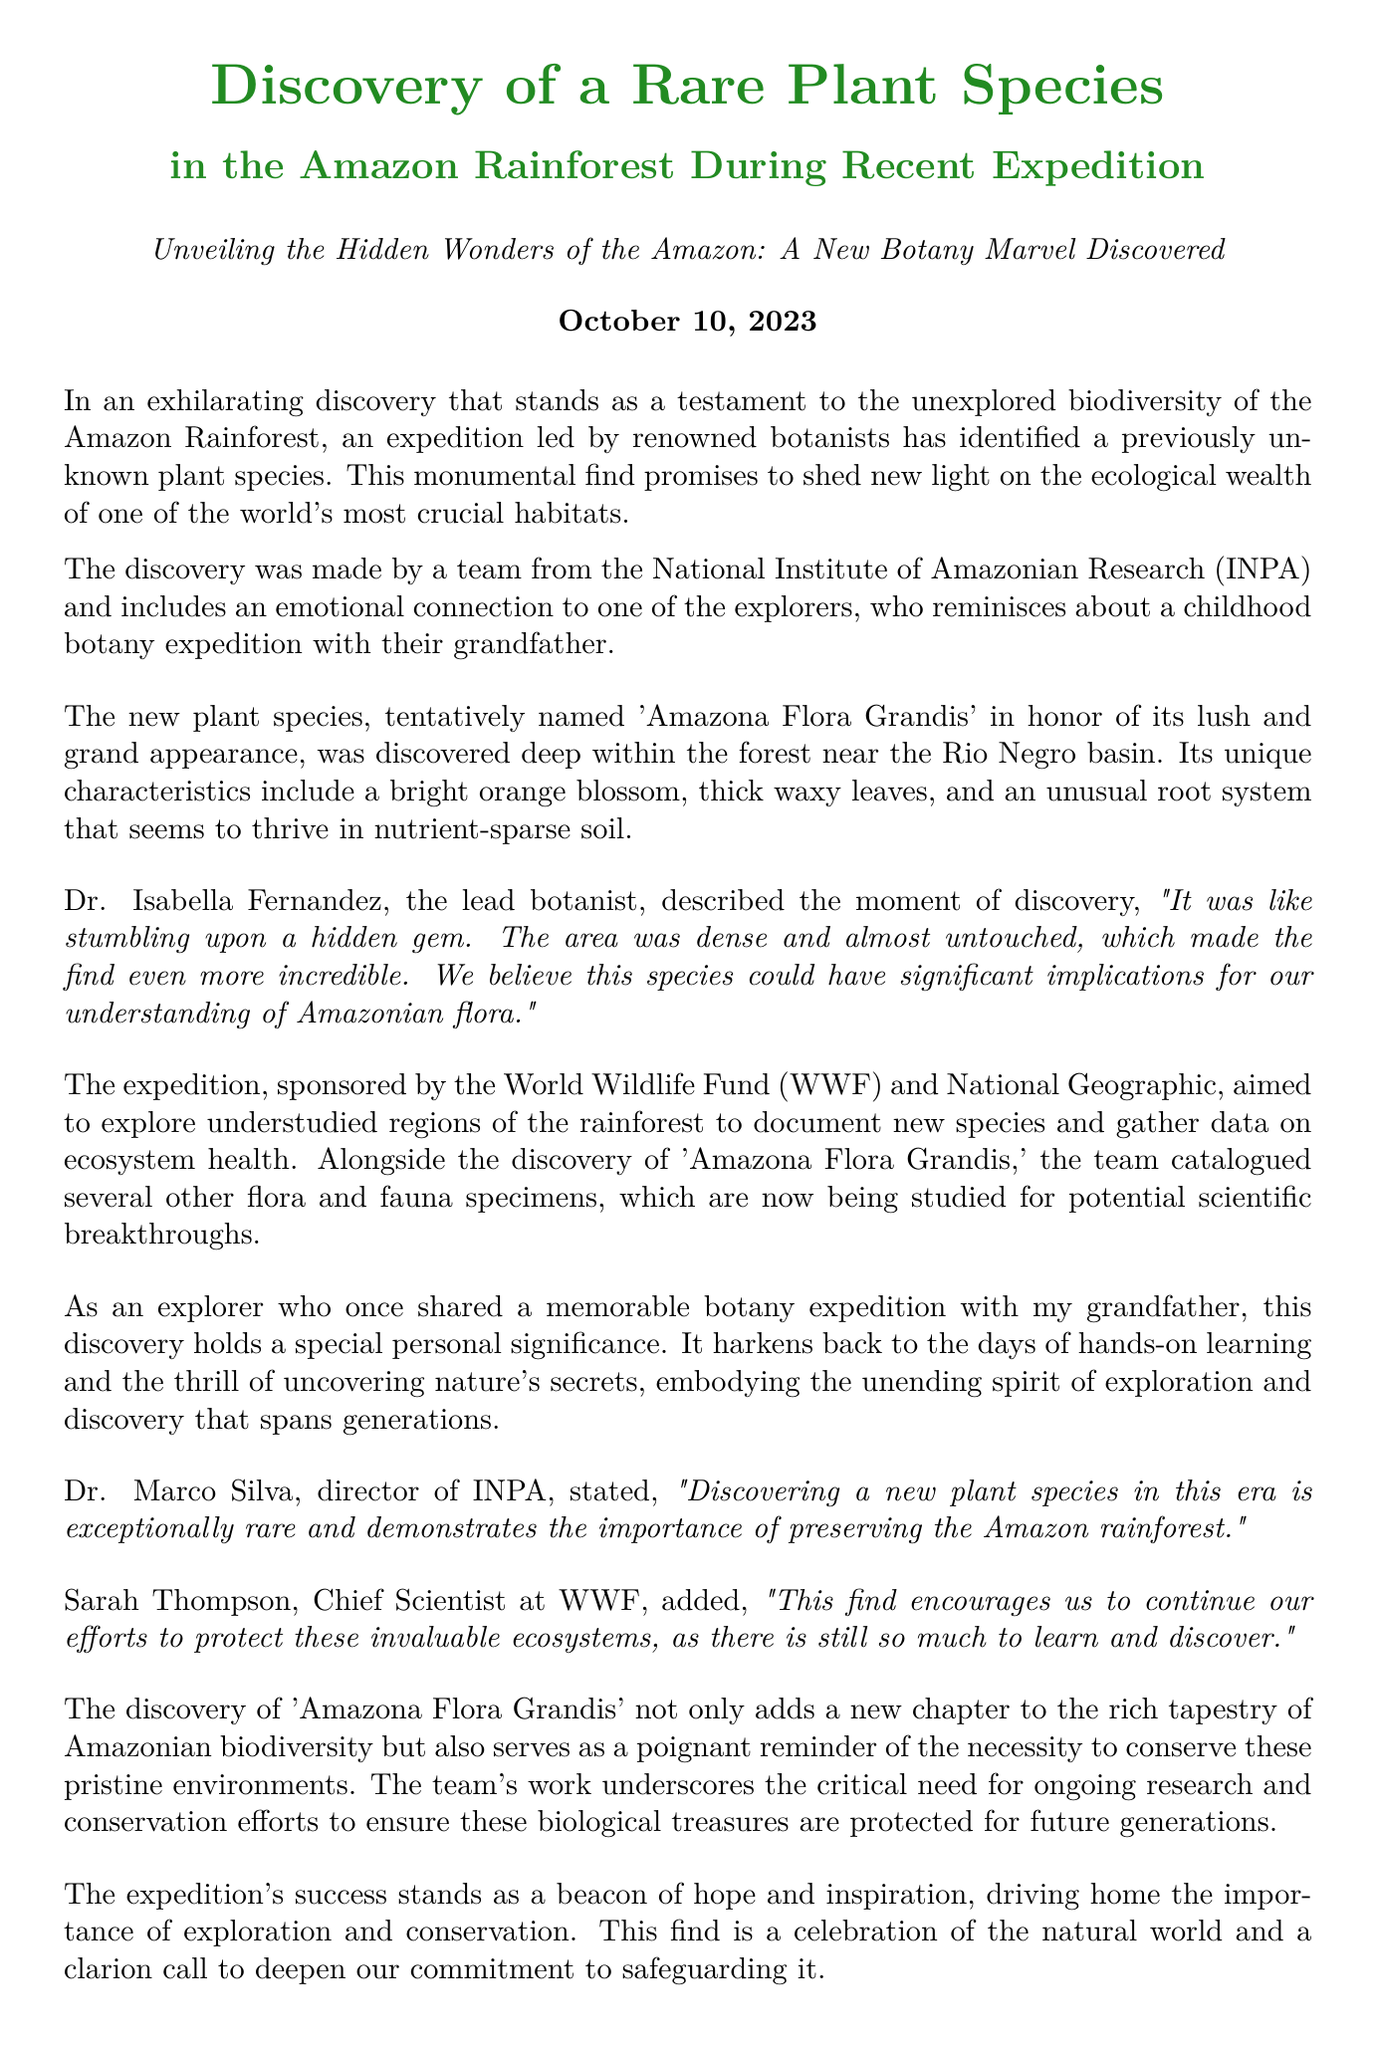What is the name of the new plant species? The new plant species is tentatively named in honor of its appearance, which is reflected in the name given in the document.
Answer: Amazona Flora Grandis Who led the expedition? The lead botanist is mentioned in the document as having described the moment of discovery, indicating her importance in the expedition.
Answer: Dr. Isabella Fernandez When was the discovery announced? The date of the press release is clearly stated at the beginning of the document, providing the timing of the announcement.
Answer: October 10, 2023 What organization sponsored the expedition? The document mentions two organizations that played a key role in funding and supporting the exploration, highlighting their involvement.
Answer: World Wildlife Fund (WWF) Where was the plant species discovered? The location of the discovery within the Amazon Rainforest is specified in the document, giving precise geographical context.
Answer: Rio Negro basin What color is the flower of the discovered plant? The document specifically describes the unique characteristics of the plant, including the color of the blossom it produces.
Answer: Bright orange What does Dr. Marco Silva emphasize about the discovery? The director of INPA made a statement regarding the significance of finding a new species, emphasizing the implications for conservation efforts.
Answer: Importance of preserving the Amazon rainforest Why is the discovery personally significant to the explorer? The document mentions a personal connection to the discovery through an experience from his childhood, reflecting a deeper emotional resonance.
Answer: Harkens back to childhood botany expedition What is the overall message of the expedition's success? The conclusion of the document succinctly conveys the message of the expedition’s findings and their importance to conservation.
Answer: Importance of exploration and conservation 